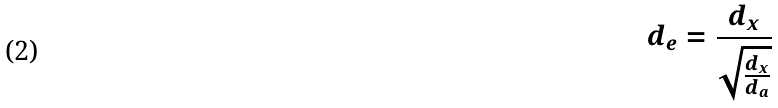<formula> <loc_0><loc_0><loc_500><loc_500>d _ { e } = \frac { d _ { x } } { \sqrt { \frac { d _ { x } } { d _ { a } } } }</formula> 